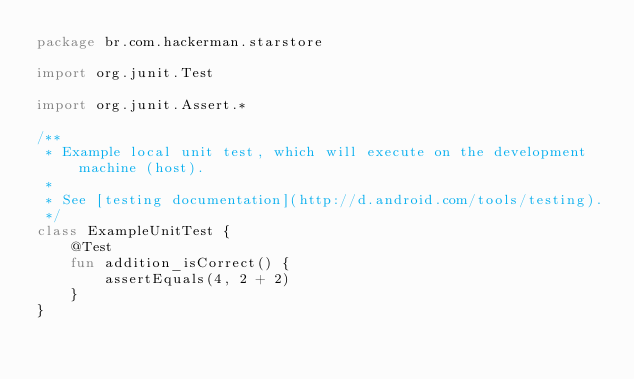<code> <loc_0><loc_0><loc_500><loc_500><_Kotlin_>package br.com.hackerman.starstore

import org.junit.Test

import org.junit.Assert.*

/**
 * Example local unit test, which will execute on the development machine (host).
 *
 * See [testing documentation](http://d.android.com/tools/testing).
 */
class ExampleUnitTest {
    @Test
    fun addition_isCorrect() {
        assertEquals(4, 2 + 2)
    }
}</code> 